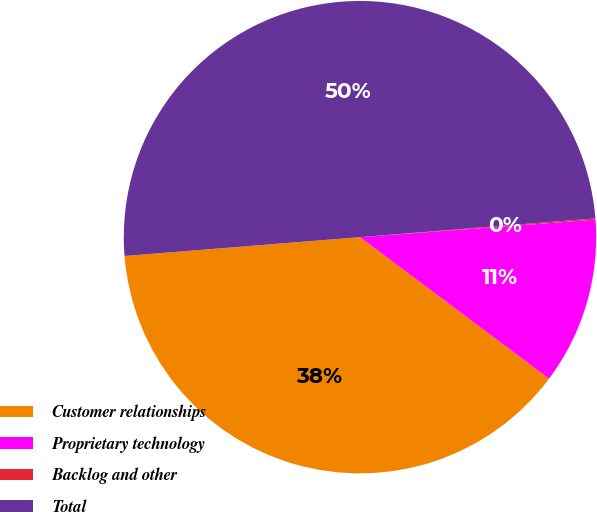Convert chart to OTSL. <chart><loc_0><loc_0><loc_500><loc_500><pie_chart><fcel>Customer relationships<fcel>Proprietary technology<fcel>Backlog and other<fcel>Total<nl><fcel>38.5%<fcel>11.41%<fcel>0.09%<fcel>50.0%<nl></chart> 